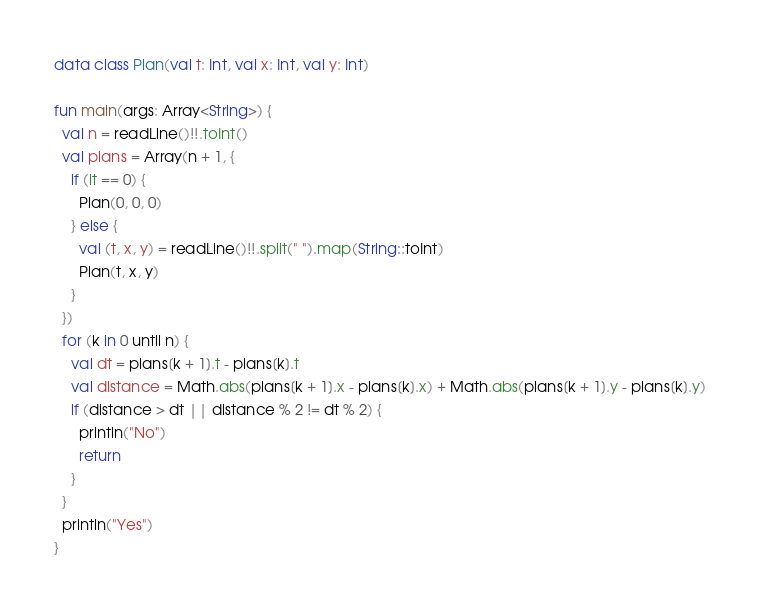Convert code to text. <code><loc_0><loc_0><loc_500><loc_500><_Kotlin_>data class Plan(val t: Int, val x: Int, val y: Int)

fun main(args: Array<String>) {
  val n = readLine()!!.toInt()
  val plans = Array(n + 1, {
    if (it == 0) {
      Plan(0, 0, 0)
    } else {
      val (t, x, y) = readLine()!!.split(" ").map(String::toInt)
      Plan(t, x, y)
    }
  })
  for (k in 0 until n) {
    val dt = plans[k + 1].t - plans[k].t
    val distance = Math.abs(plans[k + 1].x - plans[k].x) + Math.abs(plans[k + 1].y - plans[k].y)
    if (distance > dt || distance % 2 != dt % 2) {
      println("No")
      return
    }
  }
  println("Yes")
}</code> 